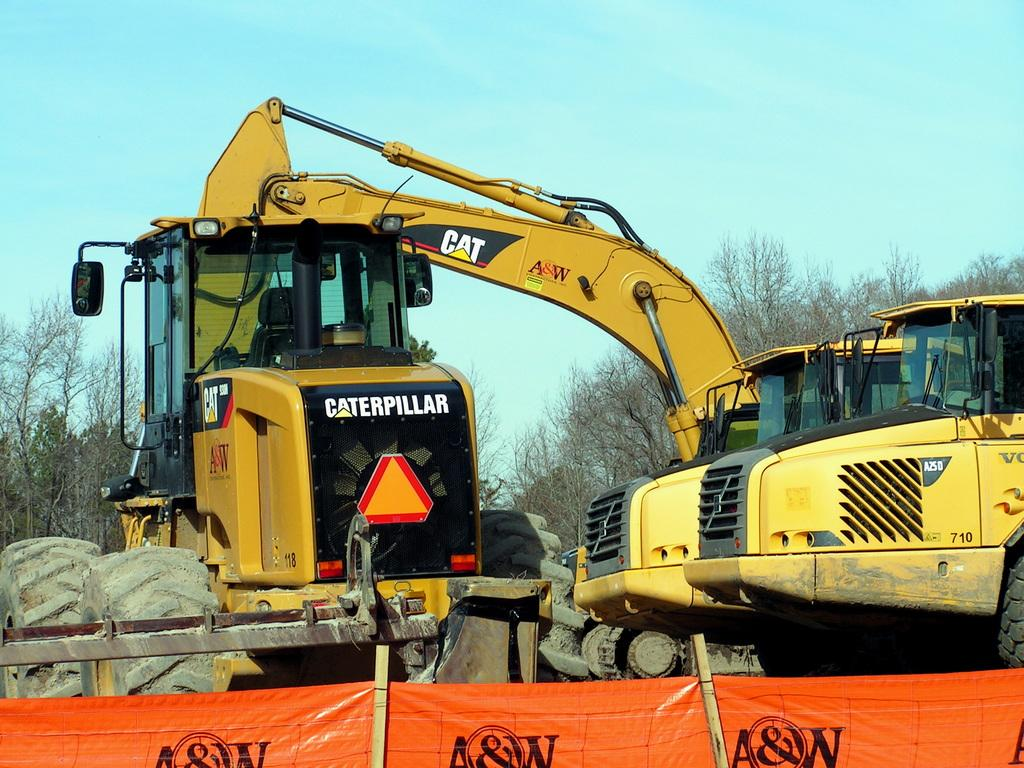What type of setting is depicted in the image? The image is an outdoor scene. What specific objects can be seen in the image? There are cranes in yellow color and an orange chart in front of the cranes. What is the color of the sky in the image? The sky is blue in the image. What type of vegetation is visible in the distance? There are bare trees in the distance. What type of art is being created by the cranes in the image? There is no indication in the image that the cranes are creating art. The cranes are likely construction equipment, not art tools. 